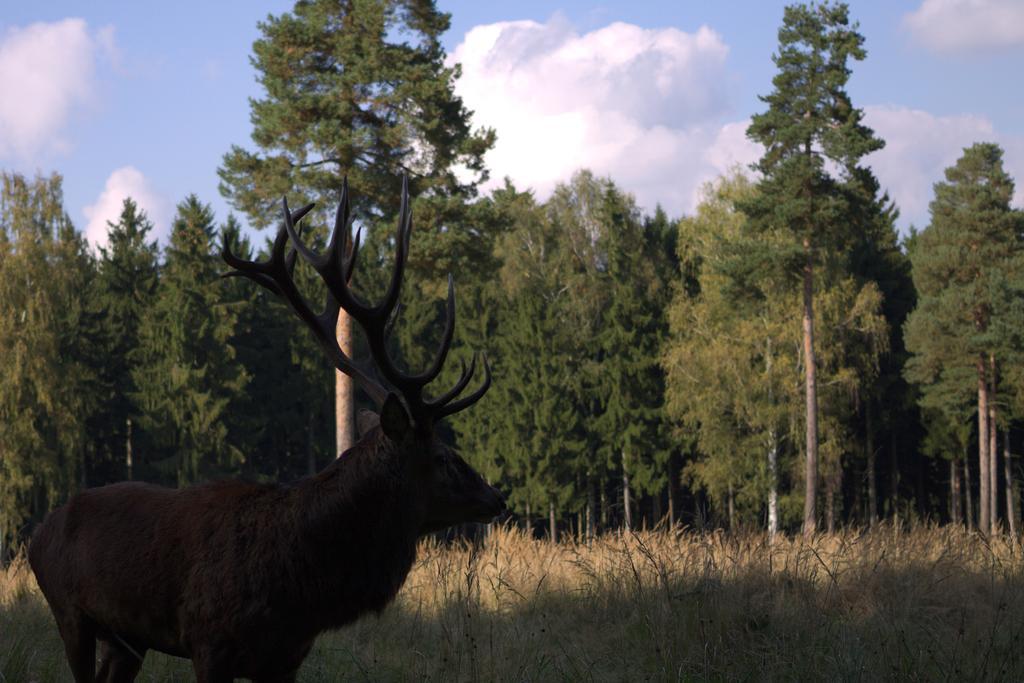Can you describe this image briefly? In this image I can see a deer is standing. In the background I can see yellow grass, number of trees, clouds and the sky. 